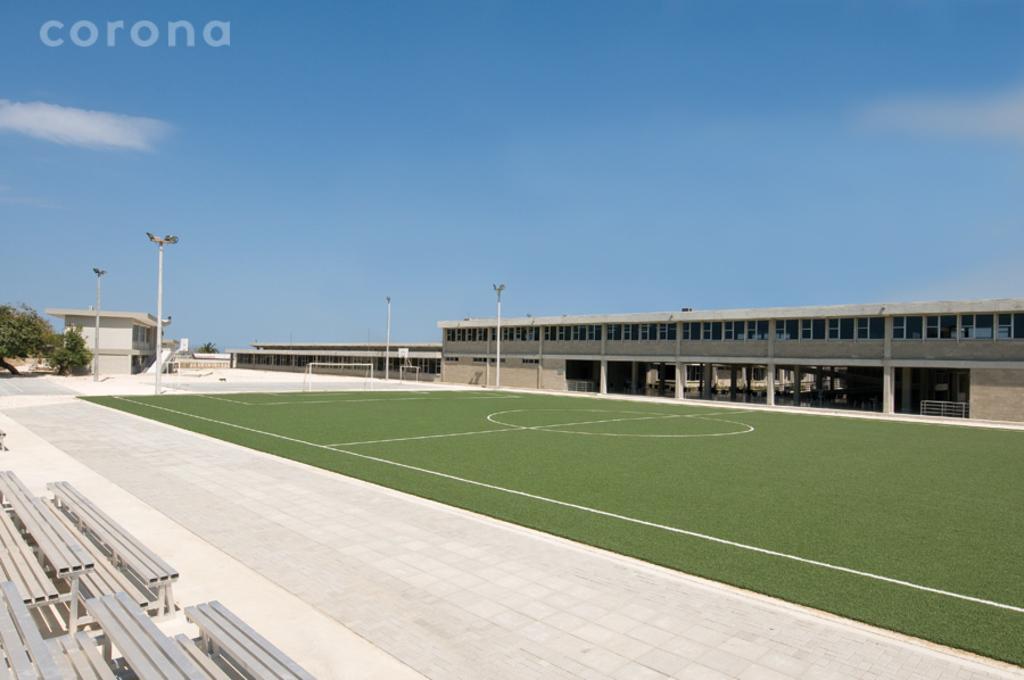Please provide a concise description of this image. In this image there are benches, lights, poles, football net, foot ball court , stadium, trees, and in the background there is sky and a watermark on the image. 